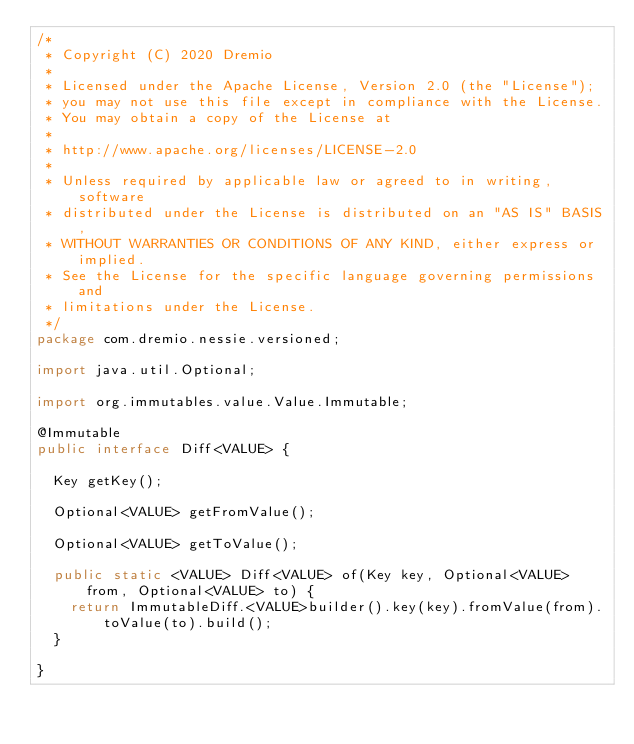<code> <loc_0><loc_0><loc_500><loc_500><_Java_>/*
 * Copyright (C) 2020 Dremio
 *
 * Licensed under the Apache License, Version 2.0 (the "License");
 * you may not use this file except in compliance with the License.
 * You may obtain a copy of the License at
 *
 * http://www.apache.org/licenses/LICENSE-2.0
 *
 * Unless required by applicable law or agreed to in writing, software
 * distributed under the License is distributed on an "AS IS" BASIS,
 * WITHOUT WARRANTIES OR CONDITIONS OF ANY KIND, either express or implied.
 * See the License for the specific language governing permissions and
 * limitations under the License.
 */
package com.dremio.nessie.versioned;

import java.util.Optional;

import org.immutables.value.Value.Immutable;

@Immutable
public interface Diff<VALUE> {

  Key getKey();

  Optional<VALUE> getFromValue();

  Optional<VALUE> getToValue();

  public static <VALUE> Diff<VALUE> of(Key key, Optional<VALUE> from, Optional<VALUE> to) {
    return ImmutableDiff.<VALUE>builder().key(key).fromValue(from).toValue(to).build();
  }

}
</code> 